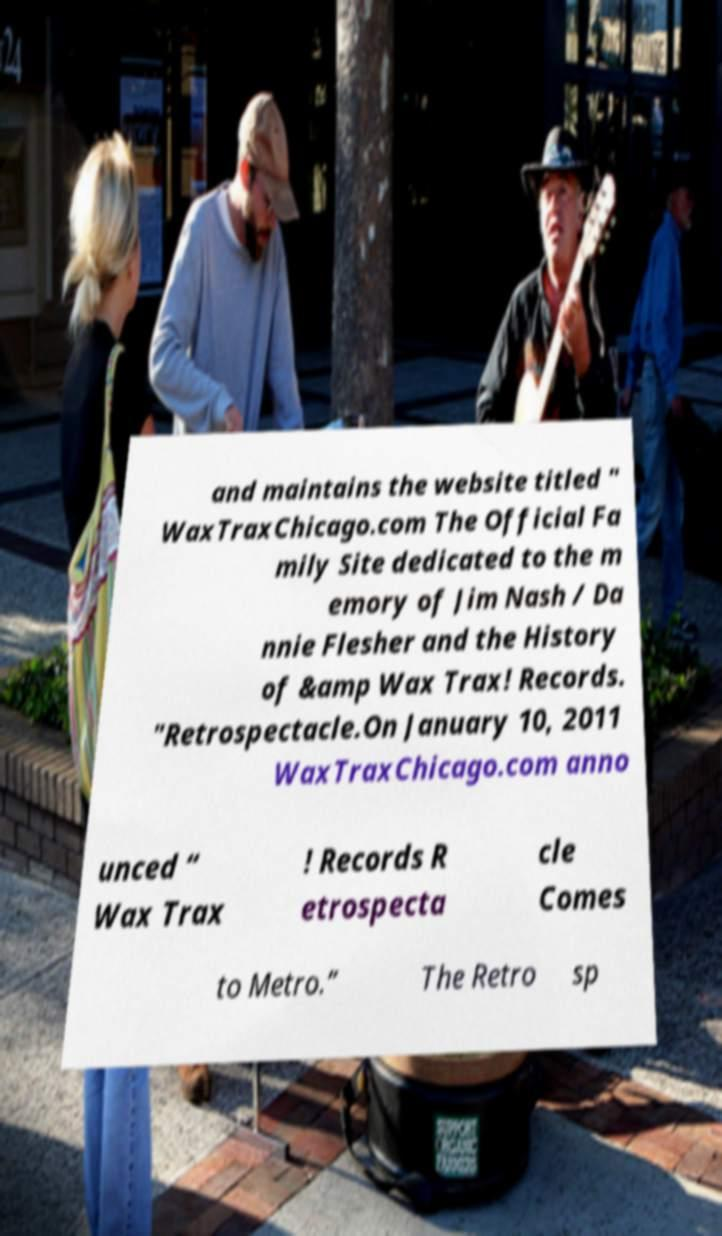Please identify and transcribe the text found in this image. and maintains the website titled " WaxTraxChicago.com The Official Fa mily Site dedicated to the m emory of Jim Nash / Da nnie Flesher and the History of &amp Wax Trax! Records. "Retrospectacle.On January 10, 2011 WaxTraxChicago.com anno unced “ Wax Trax ! Records R etrospecta cle Comes to Metro.” The Retro sp 